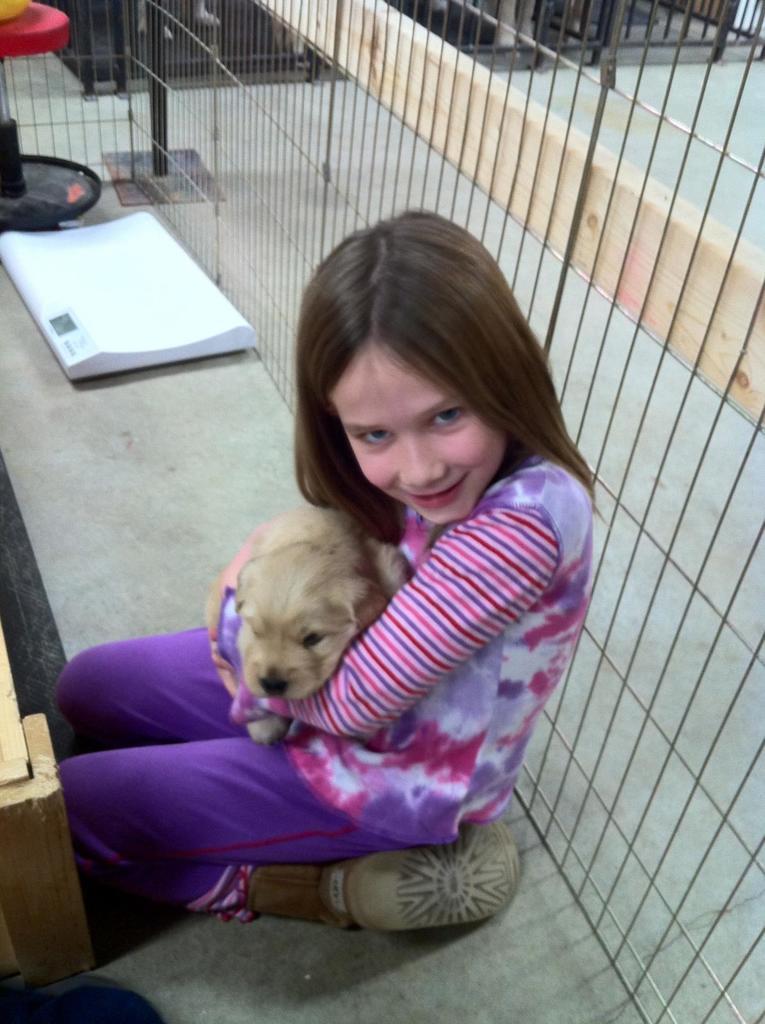In one or two sentences, can you explain what this image depicts? In this image we can see a girl is sitting on the floor. She is wearing a purple-white color dress and holding an animal in her hand. Behind her, we can see a mesh. There is a white color object and a stool like thing on the floor. 